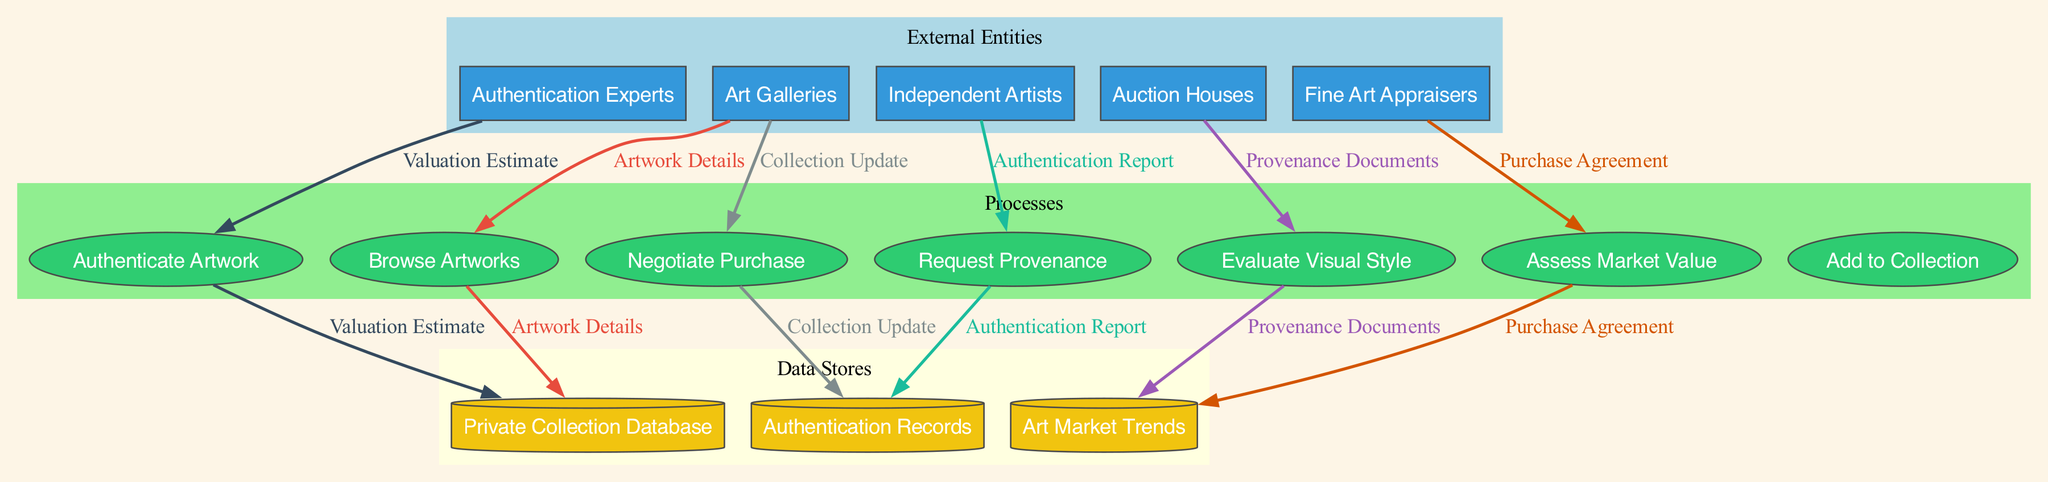What are the external entities involved in the art acquisition process? The diagram identifies five external entities: Art Galleries, Auction Houses, Independent Artists, Authentication Experts, and Fine Art Appraisers.
Answer: Art Galleries, Auction Houses, Independent Artists, Authentication Experts, Fine Art Appraisers How many processes are listed in the diagram? By counting the ellipses in the process section of the diagram, there are 7 listed processes.
Answer: 7 Which process follows the "Request Provenance" process? From the flow of the diagram, after "Request Provenance," the next process is "Authenticate Artwork."
Answer: Authenticate Artwork What is stored in the "Private Collection Database"? The diagram indicates that after adding artwork through the process, updates are stored in the "Private Collection Database."
Answer: Collection Update How many data flows are depicted in the diagram? By reviewing the connections depicting the flow of information, there are 6 distinct data flows represented within the diagram.
Answer: 6 Which external entity provides the "Authentication Report"? The flow shows that the "Authentication Experts" external entity is responsible for providing the "Authentication Report" to the "Authenticate Artwork" process.
Answer: Authentication Experts What type of document is associated with the "Negotiate Purchase" process? Following the flow, the document connected to the "Negotiate Purchase" process is the "Purchase Agreement."
Answer: Purchase Agreement Which data store contains "Authentication Records"? The diagram shows "Authentication Records" stored in one of the data stores, specifically labeled as "Authentication Records."
Answer: Authentication Records What is the final outcome of the art acquisition process? The last process in the diagram is "Add to Collection," which indicates that this is the final outcome of the entire art acquisition process.
Answer: Add to Collection 